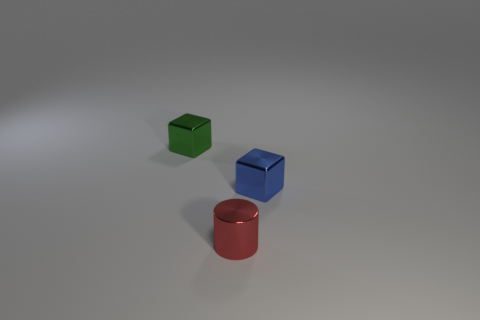Add 3 blue metallic cubes. How many objects exist? 6 Subtract all cylinders. How many objects are left? 2 Add 1 small cylinders. How many small cylinders are left? 2 Add 1 big green objects. How many big green objects exist? 1 Subtract 0 gray cylinders. How many objects are left? 3 Subtract all metal cylinders. Subtract all red objects. How many objects are left? 1 